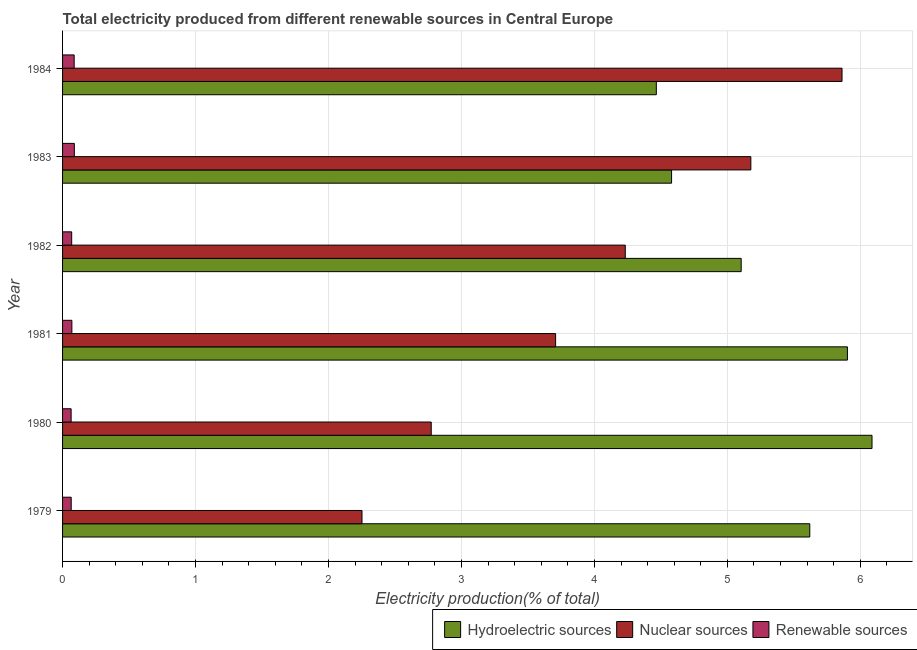How many different coloured bars are there?
Your response must be concise. 3. How many groups of bars are there?
Your response must be concise. 6. Are the number of bars per tick equal to the number of legend labels?
Ensure brevity in your answer.  Yes. What is the label of the 1st group of bars from the top?
Offer a very short reply. 1984. In how many cases, is the number of bars for a given year not equal to the number of legend labels?
Make the answer very short. 0. What is the percentage of electricity produced by nuclear sources in 1984?
Offer a terse response. 5.86. Across all years, what is the maximum percentage of electricity produced by hydroelectric sources?
Provide a short and direct response. 6.09. Across all years, what is the minimum percentage of electricity produced by hydroelectric sources?
Make the answer very short. 4.47. In which year was the percentage of electricity produced by renewable sources maximum?
Keep it short and to the point. 1983. What is the total percentage of electricity produced by nuclear sources in the graph?
Your answer should be compact. 24. What is the difference between the percentage of electricity produced by hydroelectric sources in 1980 and that in 1983?
Offer a terse response. 1.51. What is the difference between the percentage of electricity produced by renewable sources in 1980 and the percentage of electricity produced by hydroelectric sources in 1981?
Offer a terse response. -5.84. What is the average percentage of electricity produced by nuclear sources per year?
Your answer should be compact. 4. In the year 1979, what is the difference between the percentage of electricity produced by renewable sources and percentage of electricity produced by nuclear sources?
Give a very brief answer. -2.19. In how many years, is the percentage of electricity produced by nuclear sources greater than 1.2 %?
Make the answer very short. 6. What is the ratio of the percentage of electricity produced by renewable sources in 1981 to that in 1984?
Ensure brevity in your answer.  0.8. What is the difference between the highest and the second highest percentage of electricity produced by nuclear sources?
Provide a short and direct response. 0.69. What is the difference between the highest and the lowest percentage of electricity produced by nuclear sources?
Make the answer very short. 3.61. Is the sum of the percentage of electricity produced by nuclear sources in 1979 and 1982 greater than the maximum percentage of electricity produced by renewable sources across all years?
Make the answer very short. Yes. What does the 3rd bar from the top in 1981 represents?
Offer a very short reply. Hydroelectric sources. What does the 1st bar from the bottom in 1980 represents?
Your answer should be very brief. Hydroelectric sources. How many years are there in the graph?
Offer a terse response. 6. Are the values on the major ticks of X-axis written in scientific E-notation?
Provide a succinct answer. No. Does the graph contain any zero values?
Make the answer very short. No. Where does the legend appear in the graph?
Make the answer very short. Bottom right. What is the title of the graph?
Give a very brief answer. Total electricity produced from different renewable sources in Central Europe. Does "Methane" appear as one of the legend labels in the graph?
Provide a short and direct response. No. What is the label or title of the X-axis?
Give a very brief answer. Electricity production(% of total). What is the Electricity production(% of total) of Hydroelectric sources in 1979?
Your answer should be compact. 5.62. What is the Electricity production(% of total) of Nuclear sources in 1979?
Make the answer very short. 2.25. What is the Electricity production(% of total) in Renewable sources in 1979?
Your answer should be very brief. 0.06. What is the Electricity production(% of total) of Hydroelectric sources in 1980?
Give a very brief answer. 6.09. What is the Electricity production(% of total) in Nuclear sources in 1980?
Offer a terse response. 2.77. What is the Electricity production(% of total) in Renewable sources in 1980?
Give a very brief answer. 0.06. What is the Electricity production(% of total) in Hydroelectric sources in 1981?
Offer a very short reply. 5.9. What is the Electricity production(% of total) of Nuclear sources in 1981?
Your answer should be very brief. 3.71. What is the Electricity production(% of total) of Renewable sources in 1981?
Offer a terse response. 0.07. What is the Electricity production(% of total) in Hydroelectric sources in 1982?
Your answer should be very brief. 5.1. What is the Electricity production(% of total) in Nuclear sources in 1982?
Your answer should be very brief. 4.23. What is the Electricity production(% of total) in Renewable sources in 1982?
Provide a short and direct response. 0.07. What is the Electricity production(% of total) in Hydroelectric sources in 1983?
Your response must be concise. 4.58. What is the Electricity production(% of total) of Nuclear sources in 1983?
Keep it short and to the point. 5.18. What is the Electricity production(% of total) in Renewable sources in 1983?
Keep it short and to the point. 0.09. What is the Electricity production(% of total) of Hydroelectric sources in 1984?
Keep it short and to the point. 4.47. What is the Electricity production(% of total) in Nuclear sources in 1984?
Ensure brevity in your answer.  5.86. What is the Electricity production(% of total) in Renewable sources in 1984?
Make the answer very short. 0.09. Across all years, what is the maximum Electricity production(% of total) of Hydroelectric sources?
Offer a very short reply. 6.09. Across all years, what is the maximum Electricity production(% of total) of Nuclear sources?
Your answer should be very brief. 5.86. Across all years, what is the maximum Electricity production(% of total) of Renewable sources?
Give a very brief answer. 0.09. Across all years, what is the minimum Electricity production(% of total) of Hydroelectric sources?
Your answer should be compact. 4.47. Across all years, what is the minimum Electricity production(% of total) in Nuclear sources?
Make the answer very short. 2.25. Across all years, what is the minimum Electricity production(% of total) in Renewable sources?
Make the answer very short. 0.06. What is the total Electricity production(% of total) of Hydroelectric sources in the graph?
Your answer should be compact. 31.76. What is the total Electricity production(% of total) in Nuclear sources in the graph?
Keep it short and to the point. 24. What is the total Electricity production(% of total) in Renewable sources in the graph?
Your answer should be very brief. 0.44. What is the difference between the Electricity production(% of total) of Hydroelectric sources in 1979 and that in 1980?
Your response must be concise. -0.47. What is the difference between the Electricity production(% of total) in Nuclear sources in 1979 and that in 1980?
Give a very brief answer. -0.52. What is the difference between the Electricity production(% of total) of Renewable sources in 1979 and that in 1980?
Your answer should be very brief. 0. What is the difference between the Electricity production(% of total) of Hydroelectric sources in 1979 and that in 1981?
Your response must be concise. -0.28. What is the difference between the Electricity production(% of total) of Nuclear sources in 1979 and that in 1981?
Make the answer very short. -1.46. What is the difference between the Electricity production(% of total) of Renewable sources in 1979 and that in 1981?
Provide a succinct answer. -0.01. What is the difference between the Electricity production(% of total) in Hydroelectric sources in 1979 and that in 1982?
Provide a succinct answer. 0.52. What is the difference between the Electricity production(% of total) of Nuclear sources in 1979 and that in 1982?
Ensure brevity in your answer.  -1.98. What is the difference between the Electricity production(% of total) in Renewable sources in 1979 and that in 1982?
Ensure brevity in your answer.  -0. What is the difference between the Electricity production(% of total) of Hydroelectric sources in 1979 and that in 1983?
Your answer should be compact. 1.04. What is the difference between the Electricity production(% of total) of Nuclear sources in 1979 and that in 1983?
Offer a very short reply. -2.92. What is the difference between the Electricity production(% of total) in Renewable sources in 1979 and that in 1983?
Offer a very short reply. -0.02. What is the difference between the Electricity production(% of total) in Hydroelectric sources in 1979 and that in 1984?
Offer a terse response. 1.15. What is the difference between the Electricity production(% of total) of Nuclear sources in 1979 and that in 1984?
Give a very brief answer. -3.61. What is the difference between the Electricity production(% of total) of Renewable sources in 1979 and that in 1984?
Ensure brevity in your answer.  -0.02. What is the difference between the Electricity production(% of total) of Hydroelectric sources in 1980 and that in 1981?
Your answer should be very brief. 0.18. What is the difference between the Electricity production(% of total) in Nuclear sources in 1980 and that in 1981?
Your answer should be compact. -0.94. What is the difference between the Electricity production(% of total) in Renewable sources in 1980 and that in 1981?
Make the answer very short. -0.01. What is the difference between the Electricity production(% of total) of Hydroelectric sources in 1980 and that in 1982?
Make the answer very short. 0.98. What is the difference between the Electricity production(% of total) in Nuclear sources in 1980 and that in 1982?
Keep it short and to the point. -1.46. What is the difference between the Electricity production(% of total) of Renewable sources in 1980 and that in 1982?
Ensure brevity in your answer.  -0. What is the difference between the Electricity production(% of total) of Hydroelectric sources in 1980 and that in 1983?
Offer a very short reply. 1.51. What is the difference between the Electricity production(% of total) of Nuclear sources in 1980 and that in 1983?
Offer a very short reply. -2.4. What is the difference between the Electricity production(% of total) in Renewable sources in 1980 and that in 1983?
Provide a short and direct response. -0.02. What is the difference between the Electricity production(% of total) of Hydroelectric sources in 1980 and that in 1984?
Give a very brief answer. 1.62. What is the difference between the Electricity production(% of total) of Nuclear sources in 1980 and that in 1984?
Give a very brief answer. -3.09. What is the difference between the Electricity production(% of total) in Renewable sources in 1980 and that in 1984?
Provide a succinct answer. -0.02. What is the difference between the Electricity production(% of total) in Hydroelectric sources in 1981 and that in 1982?
Keep it short and to the point. 0.8. What is the difference between the Electricity production(% of total) of Nuclear sources in 1981 and that in 1982?
Provide a succinct answer. -0.52. What is the difference between the Electricity production(% of total) of Renewable sources in 1981 and that in 1982?
Give a very brief answer. 0. What is the difference between the Electricity production(% of total) in Hydroelectric sources in 1981 and that in 1983?
Your response must be concise. 1.32. What is the difference between the Electricity production(% of total) in Nuclear sources in 1981 and that in 1983?
Offer a terse response. -1.47. What is the difference between the Electricity production(% of total) of Renewable sources in 1981 and that in 1983?
Provide a succinct answer. -0.02. What is the difference between the Electricity production(% of total) in Hydroelectric sources in 1981 and that in 1984?
Your answer should be compact. 1.44. What is the difference between the Electricity production(% of total) in Nuclear sources in 1981 and that in 1984?
Provide a succinct answer. -2.15. What is the difference between the Electricity production(% of total) in Renewable sources in 1981 and that in 1984?
Your answer should be very brief. -0.02. What is the difference between the Electricity production(% of total) of Hydroelectric sources in 1982 and that in 1983?
Your answer should be very brief. 0.52. What is the difference between the Electricity production(% of total) in Nuclear sources in 1982 and that in 1983?
Offer a terse response. -0.94. What is the difference between the Electricity production(% of total) in Renewable sources in 1982 and that in 1983?
Ensure brevity in your answer.  -0.02. What is the difference between the Electricity production(% of total) in Hydroelectric sources in 1982 and that in 1984?
Provide a short and direct response. 0.64. What is the difference between the Electricity production(% of total) in Nuclear sources in 1982 and that in 1984?
Keep it short and to the point. -1.63. What is the difference between the Electricity production(% of total) of Renewable sources in 1982 and that in 1984?
Your answer should be very brief. -0.02. What is the difference between the Electricity production(% of total) in Hydroelectric sources in 1983 and that in 1984?
Provide a succinct answer. 0.11. What is the difference between the Electricity production(% of total) in Nuclear sources in 1983 and that in 1984?
Offer a very short reply. -0.69. What is the difference between the Electricity production(% of total) in Renewable sources in 1983 and that in 1984?
Make the answer very short. 0. What is the difference between the Electricity production(% of total) in Hydroelectric sources in 1979 and the Electricity production(% of total) in Nuclear sources in 1980?
Provide a succinct answer. 2.85. What is the difference between the Electricity production(% of total) of Hydroelectric sources in 1979 and the Electricity production(% of total) of Renewable sources in 1980?
Provide a short and direct response. 5.56. What is the difference between the Electricity production(% of total) of Nuclear sources in 1979 and the Electricity production(% of total) of Renewable sources in 1980?
Ensure brevity in your answer.  2.19. What is the difference between the Electricity production(% of total) of Hydroelectric sources in 1979 and the Electricity production(% of total) of Nuclear sources in 1981?
Your response must be concise. 1.91. What is the difference between the Electricity production(% of total) in Hydroelectric sources in 1979 and the Electricity production(% of total) in Renewable sources in 1981?
Provide a succinct answer. 5.55. What is the difference between the Electricity production(% of total) of Nuclear sources in 1979 and the Electricity production(% of total) of Renewable sources in 1981?
Offer a terse response. 2.18. What is the difference between the Electricity production(% of total) of Hydroelectric sources in 1979 and the Electricity production(% of total) of Nuclear sources in 1982?
Offer a terse response. 1.39. What is the difference between the Electricity production(% of total) in Hydroelectric sources in 1979 and the Electricity production(% of total) in Renewable sources in 1982?
Offer a terse response. 5.55. What is the difference between the Electricity production(% of total) in Nuclear sources in 1979 and the Electricity production(% of total) in Renewable sources in 1982?
Provide a succinct answer. 2.18. What is the difference between the Electricity production(% of total) in Hydroelectric sources in 1979 and the Electricity production(% of total) in Nuclear sources in 1983?
Offer a very short reply. 0.44. What is the difference between the Electricity production(% of total) in Hydroelectric sources in 1979 and the Electricity production(% of total) in Renewable sources in 1983?
Your response must be concise. 5.53. What is the difference between the Electricity production(% of total) in Nuclear sources in 1979 and the Electricity production(% of total) in Renewable sources in 1983?
Provide a succinct answer. 2.16. What is the difference between the Electricity production(% of total) of Hydroelectric sources in 1979 and the Electricity production(% of total) of Nuclear sources in 1984?
Offer a terse response. -0.24. What is the difference between the Electricity production(% of total) in Hydroelectric sources in 1979 and the Electricity production(% of total) in Renewable sources in 1984?
Your response must be concise. 5.53. What is the difference between the Electricity production(% of total) of Nuclear sources in 1979 and the Electricity production(% of total) of Renewable sources in 1984?
Make the answer very short. 2.16. What is the difference between the Electricity production(% of total) in Hydroelectric sources in 1980 and the Electricity production(% of total) in Nuclear sources in 1981?
Your answer should be very brief. 2.38. What is the difference between the Electricity production(% of total) of Hydroelectric sources in 1980 and the Electricity production(% of total) of Renewable sources in 1981?
Your response must be concise. 6.02. What is the difference between the Electricity production(% of total) in Nuclear sources in 1980 and the Electricity production(% of total) in Renewable sources in 1981?
Make the answer very short. 2.7. What is the difference between the Electricity production(% of total) of Hydroelectric sources in 1980 and the Electricity production(% of total) of Nuclear sources in 1982?
Your answer should be very brief. 1.86. What is the difference between the Electricity production(% of total) in Hydroelectric sources in 1980 and the Electricity production(% of total) in Renewable sources in 1982?
Offer a terse response. 6.02. What is the difference between the Electricity production(% of total) of Nuclear sources in 1980 and the Electricity production(% of total) of Renewable sources in 1982?
Your answer should be compact. 2.7. What is the difference between the Electricity production(% of total) of Hydroelectric sources in 1980 and the Electricity production(% of total) of Nuclear sources in 1983?
Provide a succinct answer. 0.91. What is the difference between the Electricity production(% of total) in Hydroelectric sources in 1980 and the Electricity production(% of total) in Renewable sources in 1983?
Keep it short and to the point. 6. What is the difference between the Electricity production(% of total) of Nuclear sources in 1980 and the Electricity production(% of total) of Renewable sources in 1983?
Make the answer very short. 2.68. What is the difference between the Electricity production(% of total) in Hydroelectric sources in 1980 and the Electricity production(% of total) in Nuclear sources in 1984?
Keep it short and to the point. 0.23. What is the difference between the Electricity production(% of total) of Hydroelectric sources in 1980 and the Electricity production(% of total) of Renewable sources in 1984?
Offer a very short reply. 6. What is the difference between the Electricity production(% of total) of Nuclear sources in 1980 and the Electricity production(% of total) of Renewable sources in 1984?
Your answer should be compact. 2.69. What is the difference between the Electricity production(% of total) in Hydroelectric sources in 1981 and the Electricity production(% of total) in Nuclear sources in 1982?
Make the answer very short. 1.67. What is the difference between the Electricity production(% of total) of Hydroelectric sources in 1981 and the Electricity production(% of total) of Renewable sources in 1982?
Offer a terse response. 5.83. What is the difference between the Electricity production(% of total) of Nuclear sources in 1981 and the Electricity production(% of total) of Renewable sources in 1982?
Your response must be concise. 3.64. What is the difference between the Electricity production(% of total) of Hydroelectric sources in 1981 and the Electricity production(% of total) of Nuclear sources in 1983?
Provide a short and direct response. 0.73. What is the difference between the Electricity production(% of total) in Hydroelectric sources in 1981 and the Electricity production(% of total) in Renewable sources in 1983?
Offer a terse response. 5.81. What is the difference between the Electricity production(% of total) in Nuclear sources in 1981 and the Electricity production(% of total) in Renewable sources in 1983?
Provide a short and direct response. 3.62. What is the difference between the Electricity production(% of total) of Hydroelectric sources in 1981 and the Electricity production(% of total) of Nuclear sources in 1984?
Ensure brevity in your answer.  0.04. What is the difference between the Electricity production(% of total) of Hydroelectric sources in 1981 and the Electricity production(% of total) of Renewable sources in 1984?
Offer a very short reply. 5.82. What is the difference between the Electricity production(% of total) in Nuclear sources in 1981 and the Electricity production(% of total) in Renewable sources in 1984?
Your answer should be compact. 3.62. What is the difference between the Electricity production(% of total) of Hydroelectric sources in 1982 and the Electricity production(% of total) of Nuclear sources in 1983?
Make the answer very short. -0.07. What is the difference between the Electricity production(% of total) in Hydroelectric sources in 1982 and the Electricity production(% of total) in Renewable sources in 1983?
Your answer should be compact. 5.02. What is the difference between the Electricity production(% of total) in Nuclear sources in 1982 and the Electricity production(% of total) in Renewable sources in 1983?
Offer a very short reply. 4.14. What is the difference between the Electricity production(% of total) in Hydroelectric sources in 1982 and the Electricity production(% of total) in Nuclear sources in 1984?
Give a very brief answer. -0.76. What is the difference between the Electricity production(% of total) in Hydroelectric sources in 1982 and the Electricity production(% of total) in Renewable sources in 1984?
Offer a terse response. 5.02. What is the difference between the Electricity production(% of total) of Nuclear sources in 1982 and the Electricity production(% of total) of Renewable sources in 1984?
Make the answer very short. 4.14. What is the difference between the Electricity production(% of total) in Hydroelectric sources in 1983 and the Electricity production(% of total) in Nuclear sources in 1984?
Offer a very short reply. -1.28. What is the difference between the Electricity production(% of total) of Hydroelectric sources in 1983 and the Electricity production(% of total) of Renewable sources in 1984?
Offer a very short reply. 4.49. What is the difference between the Electricity production(% of total) of Nuclear sources in 1983 and the Electricity production(% of total) of Renewable sources in 1984?
Make the answer very short. 5.09. What is the average Electricity production(% of total) in Hydroelectric sources per year?
Keep it short and to the point. 5.29. What is the average Electricity production(% of total) of Nuclear sources per year?
Offer a very short reply. 4. What is the average Electricity production(% of total) of Renewable sources per year?
Give a very brief answer. 0.07. In the year 1979, what is the difference between the Electricity production(% of total) in Hydroelectric sources and Electricity production(% of total) in Nuclear sources?
Your answer should be very brief. 3.37. In the year 1979, what is the difference between the Electricity production(% of total) of Hydroelectric sources and Electricity production(% of total) of Renewable sources?
Offer a very short reply. 5.55. In the year 1979, what is the difference between the Electricity production(% of total) in Nuclear sources and Electricity production(% of total) in Renewable sources?
Offer a very short reply. 2.19. In the year 1980, what is the difference between the Electricity production(% of total) in Hydroelectric sources and Electricity production(% of total) in Nuclear sources?
Offer a terse response. 3.32. In the year 1980, what is the difference between the Electricity production(% of total) of Hydroelectric sources and Electricity production(% of total) of Renewable sources?
Offer a very short reply. 6.02. In the year 1980, what is the difference between the Electricity production(% of total) in Nuclear sources and Electricity production(% of total) in Renewable sources?
Ensure brevity in your answer.  2.71. In the year 1981, what is the difference between the Electricity production(% of total) in Hydroelectric sources and Electricity production(% of total) in Nuclear sources?
Keep it short and to the point. 2.19. In the year 1981, what is the difference between the Electricity production(% of total) in Hydroelectric sources and Electricity production(% of total) in Renewable sources?
Make the answer very short. 5.83. In the year 1981, what is the difference between the Electricity production(% of total) in Nuclear sources and Electricity production(% of total) in Renewable sources?
Offer a very short reply. 3.64. In the year 1982, what is the difference between the Electricity production(% of total) of Hydroelectric sources and Electricity production(% of total) of Nuclear sources?
Keep it short and to the point. 0.87. In the year 1982, what is the difference between the Electricity production(% of total) in Hydroelectric sources and Electricity production(% of total) in Renewable sources?
Offer a very short reply. 5.04. In the year 1982, what is the difference between the Electricity production(% of total) in Nuclear sources and Electricity production(% of total) in Renewable sources?
Your response must be concise. 4.16. In the year 1983, what is the difference between the Electricity production(% of total) in Hydroelectric sources and Electricity production(% of total) in Nuclear sources?
Offer a very short reply. -0.6. In the year 1983, what is the difference between the Electricity production(% of total) of Hydroelectric sources and Electricity production(% of total) of Renewable sources?
Provide a short and direct response. 4.49. In the year 1983, what is the difference between the Electricity production(% of total) in Nuclear sources and Electricity production(% of total) in Renewable sources?
Provide a succinct answer. 5.09. In the year 1984, what is the difference between the Electricity production(% of total) in Hydroelectric sources and Electricity production(% of total) in Nuclear sources?
Make the answer very short. -1.4. In the year 1984, what is the difference between the Electricity production(% of total) in Hydroelectric sources and Electricity production(% of total) in Renewable sources?
Your answer should be compact. 4.38. In the year 1984, what is the difference between the Electricity production(% of total) of Nuclear sources and Electricity production(% of total) of Renewable sources?
Give a very brief answer. 5.78. What is the ratio of the Electricity production(% of total) of Hydroelectric sources in 1979 to that in 1980?
Your response must be concise. 0.92. What is the ratio of the Electricity production(% of total) of Nuclear sources in 1979 to that in 1980?
Provide a succinct answer. 0.81. What is the ratio of the Electricity production(% of total) of Renewable sources in 1979 to that in 1980?
Your answer should be very brief. 1.01. What is the ratio of the Electricity production(% of total) of Hydroelectric sources in 1979 to that in 1981?
Give a very brief answer. 0.95. What is the ratio of the Electricity production(% of total) of Nuclear sources in 1979 to that in 1981?
Make the answer very short. 0.61. What is the ratio of the Electricity production(% of total) in Renewable sources in 1979 to that in 1981?
Your response must be concise. 0.93. What is the ratio of the Electricity production(% of total) of Hydroelectric sources in 1979 to that in 1982?
Your answer should be compact. 1.1. What is the ratio of the Electricity production(% of total) of Nuclear sources in 1979 to that in 1982?
Keep it short and to the point. 0.53. What is the ratio of the Electricity production(% of total) in Renewable sources in 1979 to that in 1982?
Make the answer very short. 0.95. What is the ratio of the Electricity production(% of total) in Hydroelectric sources in 1979 to that in 1983?
Make the answer very short. 1.23. What is the ratio of the Electricity production(% of total) of Nuclear sources in 1979 to that in 1983?
Your answer should be compact. 0.43. What is the ratio of the Electricity production(% of total) of Renewable sources in 1979 to that in 1983?
Offer a very short reply. 0.73. What is the ratio of the Electricity production(% of total) in Hydroelectric sources in 1979 to that in 1984?
Offer a terse response. 1.26. What is the ratio of the Electricity production(% of total) in Nuclear sources in 1979 to that in 1984?
Give a very brief answer. 0.38. What is the ratio of the Electricity production(% of total) in Renewable sources in 1979 to that in 1984?
Your response must be concise. 0.74. What is the ratio of the Electricity production(% of total) in Hydroelectric sources in 1980 to that in 1981?
Make the answer very short. 1.03. What is the ratio of the Electricity production(% of total) in Nuclear sources in 1980 to that in 1981?
Your response must be concise. 0.75. What is the ratio of the Electricity production(% of total) in Renewable sources in 1980 to that in 1981?
Offer a terse response. 0.92. What is the ratio of the Electricity production(% of total) of Hydroelectric sources in 1980 to that in 1982?
Offer a very short reply. 1.19. What is the ratio of the Electricity production(% of total) in Nuclear sources in 1980 to that in 1982?
Provide a short and direct response. 0.66. What is the ratio of the Electricity production(% of total) in Renewable sources in 1980 to that in 1982?
Keep it short and to the point. 0.94. What is the ratio of the Electricity production(% of total) in Hydroelectric sources in 1980 to that in 1983?
Make the answer very short. 1.33. What is the ratio of the Electricity production(% of total) of Nuclear sources in 1980 to that in 1983?
Your answer should be compact. 0.54. What is the ratio of the Electricity production(% of total) of Renewable sources in 1980 to that in 1983?
Offer a terse response. 0.73. What is the ratio of the Electricity production(% of total) of Hydroelectric sources in 1980 to that in 1984?
Offer a terse response. 1.36. What is the ratio of the Electricity production(% of total) in Nuclear sources in 1980 to that in 1984?
Give a very brief answer. 0.47. What is the ratio of the Electricity production(% of total) of Renewable sources in 1980 to that in 1984?
Provide a short and direct response. 0.74. What is the ratio of the Electricity production(% of total) of Hydroelectric sources in 1981 to that in 1982?
Your answer should be compact. 1.16. What is the ratio of the Electricity production(% of total) of Nuclear sources in 1981 to that in 1982?
Offer a terse response. 0.88. What is the ratio of the Electricity production(% of total) of Renewable sources in 1981 to that in 1982?
Make the answer very short. 1.02. What is the ratio of the Electricity production(% of total) in Hydroelectric sources in 1981 to that in 1983?
Your answer should be very brief. 1.29. What is the ratio of the Electricity production(% of total) in Nuclear sources in 1981 to that in 1983?
Keep it short and to the point. 0.72. What is the ratio of the Electricity production(% of total) of Renewable sources in 1981 to that in 1983?
Ensure brevity in your answer.  0.79. What is the ratio of the Electricity production(% of total) of Hydroelectric sources in 1981 to that in 1984?
Your answer should be very brief. 1.32. What is the ratio of the Electricity production(% of total) of Nuclear sources in 1981 to that in 1984?
Keep it short and to the point. 0.63. What is the ratio of the Electricity production(% of total) of Renewable sources in 1981 to that in 1984?
Your answer should be very brief. 0.8. What is the ratio of the Electricity production(% of total) of Hydroelectric sources in 1982 to that in 1983?
Provide a short and direct response. 1.11. What is the ratio of the Electricity production(% of total) in Nuclear sources in 1982 to that in 1983?
Ensure brevity in your answer.  0.82. What is the ratio of the Electricity production(% of total) in Renewable sources in 1982 to that in 1983?
Ensure brevity in your answer.  0.77. What is the ratio of the Electricity production(% of total) in Hydroelectric sources in 1982 to that in 1984?
Provide a short and direct response. 1.14. What is the ratio of the Electricity production(% of total) of Nuclear sources in 1982 to that in 1984?
Provide a short and direct response. 0.72. What is the ratio of the Electricity production(% of total) of Renewable sources in 1982 to that in 1984?
Make the answer very short. 0.79. What is the ratio of the Electricity production(% of total) of Hydroelectric sources in 1983 to that in 1984?
Make the answer very short. 1.03. What is the ratio of the Electricity production(% of total) of Nuclear sources in 1983 to that in 1984?
Keep it short and to the point. 0.88. What is the ratio of the Electricity production(% of total) in Renewable sources in 1983 to that in 1984?
Offer a terse response. 1.02. What is the difference between the highest and the second highest Electricity production(% of total) in Hydroelectric sources?
Ensure brevity in your answer.  0.18. What is the difference between the highest and the second highest Electricity production(% of total) in Nuclear sources?
Make the answer very short. 0.69. What is the difference between the highest and the second highest Electricity production(% of total) in Renewable sources?
Your answer should be compact. 0. What is the difference between the highest and the lowest Electricity production(% of total) in Hydroelectric sources?
Offer a very short reply. 1.62. What is the difference between the highest and the lowest Electricity production(% of total) in Nuclear sources?
Your answer should be compact. 3.61. What is the difference between the highest and the lowest Electricity production(% of total) of Renewable sources?
Your response must be concise. 0.02. 